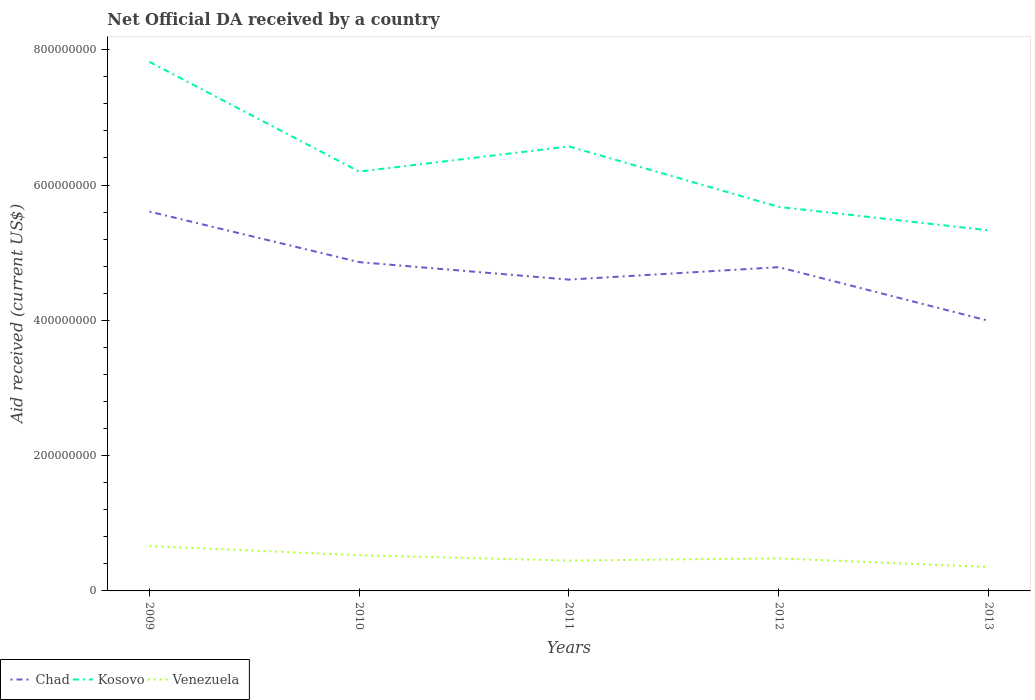Is the number of lines equal to the number of legend labels?
Your response must be concise. Yes. Across all years, what is the maximum net official development assistance aid received in Chad?
Provide a short and direct response. 3.99e+08. What is the total net official development assistance aid received in Kosovo in the graph?
Keep it short and to the point. -3.72e+07. What is the difference between the highest and the second highest net official development assistance aid received in Kosovo?
Keep it short and to the point. 2.49e+08. Is the net official development assistance aid received in Venezuela strictly greater than the net official development assistance aid received in Chad over the years?
Give a very brief answer. Yes. Are the values on the major ticks of Y-axis written in scientific E-notation?
Your response must be concise. No. How many legend labels are there?
Provide a short and direct response. 3. What is the title of the graph?
Give a very brief answer. Net Official DA received by a country. What is the label or title of the X-axis?
Offer a terse response. Years. What is the label or title of the Y-axis?
Offer a very short reply. Aid received (current US$). What is the Aid received (current US$) of Chad in 2009?
Ensure brevity in your answer.  5.61e+08. What is the Aid received (current US$) of Kosovo in 2009?
Offer a terse response. 7.82e+08. What is the Aid received (current US$) in Venezuela in 2009?
Offer a very short reply. 6.63e+07. What is the Aid received (current US$) in Chad in 2010?
Keep it short and to the point. 4.86e+08. What is the Aid received (current US$) of Kosovo in 2010?
Your response must be concise. 6.20e+08. What is the Aid received (current US$) of Venezuela in 2010?
Offer a very short reply. 5.27e+07. What is the Aid received (current US$) in Chad in 2011?
Your answer should be compact. 4.60e+08. What is the Aid received (current US$) of Kosovo in 2011?
Provide a short and direct response. 6.57e+08. What is the Aid received (current US$) in Venezuela in 2011?
Your answer should be very brief. 4.49e+07. What is the Aid received (current US$) of Chad in 2012?
Give a very brief answer. 4.79e+08. What is the Aid received (current US$) of Kosovo in 2012?
Ensure brevity in your answer.  5.68e+08. What is the Aid received (current US$) in Venezuela in 2012?
Ensure brevity in your answer.  4.81e+07. What is the Aid received (current US$) in Chad in 2013?
Provide a short and direct response. 3.99e+08. What is the Aid received (current US$) in Kosovo in 2013?
Your answer should be compact. 5.33e+08. What is the Aid received (current US$) of Venezuela in 2013?
Give a very brief answer. 3.54e+07. Across all years, what is the maximum Aid received (current US$) in Chad?
Your answer should be very brief. 5.61e+08. Across all years, what is the maximum Aid received (current US$) in Kosovo?
Your answer should be very brief. 7.82e+08. Across all years, what is the maximum Aid received (current US$) of Venezuela?
Provide a short and direct response. 6.63e+07. Across all years, what is the minimum Aid received (current US$) in Chad?
Ensure brevity in your answer.  3.99e+08. Across all years, what is the minimum Aid received (current US$) in Kosovo?
Your answer should be compact. 5.33e+08. Across all years, what is the minimum Aid received (current US$) of Venezuela?
Your answer should be very brief. 3.54e+07. What is the total Aid received (current US$) in Chad in the graph?
Offer a terse response. 2.38e+09. What is the total Aid received (current US$) in Kosovo in the graph?
Your response must be concise. 3.16e+09. What is the total Aid received (current US$) of Venezuela in the graph?
Provide a succinct answer. 2.47e+08. What is the difference between the Aid received (current US$) of Chad in 2009 and that in 2010?
Give a very brief answer. 7.47e+07. What is the difference between the Aid received (current US$) in Kosovo in 2009 and that in 2010?
Give a very brief answer. 1.62e+08. What is the difference between the Aid received (current US$) in Venezuela in 2009 and that in 2010?
Give a very brief answer. 1.36e+07. What is the difference between the Aid received (current US$) of Chad in 2009 and that in 2011?
Give a very brief answer. 1.01e+08. What is the difference between the Aid received (current US$) of Kosovo in 2009 and that in 2011?
Provide a succinct answer. 1.25e+08. What is the difference between the Aid received (current US$) in Venezuela in 2009 and that in 2011?
Your response must be concise. 2.15e+07. What is the difference between the Aid received (current US$) of Chad in 2009 and that in 2012?
Your response must be concise. 8.21e+07. What is the difference between the Aid received (current US$) in Kosovo in 2009 and that in 2012?
Keep it short and to the point. 2.14e+08. What is the difference between the Aid received (current US$) of Venezuela in 2009 and that in 2012?
Your response must be concise. 1.82e+07. What is the difference between the Aid received (current US$) in Chad in 2009 and that in 2013?
Ensure brevity in your answer.  1.61e+08. What is the difference between the Aid received (current US$) of Kosovo in 2009 and that in 2013?
Make the answer very short. 2.49e+08. What is the difference between the Aid received (current US$) in Venezuela in 2009 and that in 2013?
Your answer should be compact. 3.09e+07. What is the difference between the Aid received (current US$) of Chad in 2010 and that in 2011?
Provide a short and direct response. 2.58e+07. What is the difference between the Aid received (current US$) in Kosovo in 2010 and that in 2011?
Your answer should be very brief. -3.72e+07. What is the difference between the Aid received (current US$) in Venezuela in 2010 and that in 2011?
Your answer should be compact. 7.87e+06. What is the difference between the Aid received (current US$) of Chad in 2010 and that in 2012?
Offer a terse response. 7.45e+06. What is the difference between the Aid received (current US$) of Kosovo in 2010 and that in 2012?
Your answer should be compact. 5.22e+07. What is the difference between the Aid received (current US$) of Venezuela in 2010 and that in 2012?
Offer a very short reply. 4.61e+06. What is the difference between the Aid received (current US$) in Chad in 2010 and that in 2013?
Provide a succinct answer. 8.67e+07. What is the difference between the Aid received (current US$) in Kosovo in 2010 and that in 2013?
Keep it short and to the point. 8.68e+07. What is the difference between the Aid received (current US$) in Venezuela in 2010 and that in 2013?
Offer a terse response. 1.73e+07. What is the difference between the Aid received (current US$) in Chad in 2011 and that in 2012?
Ensure brevity in your answer.  -1.84e+07. What is the difference between the Aid received (current US$) in Kosovo in 2011 and that in 2012?
Your answer should be very brief. 8.94e+07. What is the difference between the Aid received (current US$) in Venezuela in 2011 and that in 2012?
Ensure brevity in your answer.  -3.26e+06. What is the difference between the Aid received (current US$) of Chad in 2011 and that in 2013?
Your answer should be very brief. 6.09e+07. What is the difference between the Aid received (current US$) in Kosovo in 2011 and that in 2013?
Offer a very short reply. 1.24e+08. What is the difference between the Aid received (current US$) of Venezuela in 2011 and that in 2013?
Your answer should be compact. 9.47e+06. What is the difference between the Aid received (current US$) of Chad in 2012 and that in 2013?
Provide a succinct answer. 7.93e+07. What is the difference between the Aid received (current US$) of Kosovo in 2012 and that in 2013?
Give a very brief answer. 3.46e+07. What is the difference between the Aid received (current US$) in Venezuela in 2012 and that in 2013?
Offer a very short reply. 1.27e+07. What is the difference between the Aid received (current US$) of Chad in 2009 and the Aid received (current US$) of Kosovo in 2010?
Your answer should be very brief. -5.91e+07. What is the difference between the Aid received (current US$) in Chad in 2009 and the Aid received (current US$) in Venezuela in 2010?
Keep it short and to the point. 5.08e+08. What is the difference between the Aid received (current US$) in Kosovo in 2009 and the Aid received (current US$) in Venezuela in 2010?
Give a very brief answer. 7.29e+08. What is the difference between the Aid received (current US$) of Chad in 2009 and the Aid received (current US$) of Kosovo in 2011?
Ensure brevity in your answer.  -9.64e+07. What is the difference between the Aid received (current US$) of Chad in 2009 and the Aid received (current US$) of Venezuela in 2011?
Offer a terse response. 5.16e+08. What is the difference between the Aid received (current US$) of Kosovo in 2009 and the Aid received (current US$) of Venezuela in 2011?
Keep it short and to the point. 7.37e+08. What is the difference between the Aid received (current US$) in Chad in 2009 and the Aid received (current US$) in Kosovo in 2012?
Provide a succinct answer. -6.95e+06. What is the difference between the Aid received (current US$) in Chad in 2009 and the Aid received (current US$) in Venezuela in 2012?
Offer a terse response. 5.13e+08. What is the difference between the Aid received (current US$) in Kosovo in 2009 and the Aid received (current US$) in Venezuela in 2012?
Offer a very short reply. 7.34e+08. What is the difference between the Aid received (current US$) in Chad in 2009 and the Aid received (current US$) in Kosovo in 2013?
Provide a short and direct response. 2.77e+07. What is the difference between the Aid received (current US$) of Chad in 2009 and the Aid received (current US$) of Venezuela in 2013?
Your response must be concise. 5.25e+08. What is the difference between the Aid received (current US$) in Kosovo in 2009 and the Aid received (current US$) in Venezuela in 2013?
Provide a short and direct response. 7.47e+08. What is the difference between the Aid received (current US$) of Chad in 2010 and the Aid received (current US$) of Kosovo in 2011?
Keep it short and to the point. -1.71e+08. What is the difference between the Aid received (current US$) of Chad in 2010 and the Aid received (current US$) of Venezuela in 2011?
Give a very brief answer. 4.41e+08. What is the difference between the Aid received (current US$) of Kosovo in 2010 and the Aid received (current US$) of Venezuela in 2011?
Your response must be concise. 5.75e+08. What is the difference between the Aid received (current US$) in Chad in 2010 and the Aid received (current US$) in Kosovo in 2012?
Your answer should be very brief. -8.16e+07. What is the difference between the Aid received (current US$) in Chad in 2010 and the Aid received (current US$) in Venezuela in 2012?
Your answer should be very brief. 4.38e+08. What is the difference between the Aid received (current US$) of Kosovo in 2010 and the Aid received (current US$) of Venezuela in 2012?
Provide a succinct answer. 5.72e+08. What is the difference between the Aid received (current US$) of Chad in 2010 and the Aid received (current US$) of Kosovo in 2013?
Offer a terse response. -4.70e+07. What is the difference between the Aid received (current US$) in Chad in 2010 and the Aid received (current US$) in Venezuela in 2013?
Provide a succinct answer. 4.51e+08. What is the difference between the Aid received (current US$) in Kosovo in 2010 and the Aid received (current US$) in Venezuela in 2013?
Your answer should be very brief. 5.84e+08. What is the difference between the Aid received (current US$) in Chad in 2011 and the Aid received (current US$) in Kosovo in 2012?
Give a very brief answer. -1.07e+08. What is the difference between the Aid received (current US$) in Chad in 2011 and the Aid received (current US$) in Venezuela in 2012?
Offer a terse response. 4.12e+08. What is the difference between the Aid received (current US$) of Kosovo in 2011 and the Aid received (current US$) of Venezuela in 2012?
Give a very brief answer. 6.09e+08. What is the difference between the Aid received (current US$) in Chad in 2011 and the Aid received (current US$) in Kosovo in 2013?
Provide a succinct answer. -7.28e+07. What is the difference between the Aid received (current US$) in Chad in 2011 and the Aid received (current US$) in Venezuela in 2013?
Your answer should be very brief. 4.25e+08. What is the difference between the Aid received (current US$) in Kosovo in 2011 and the Aid received (current US$) in Venezuela in 2013?
Your answer should be very brief. 6.22e+08. What is the difference between the Aid received (current US$) of Chad in 2012 and the Aid received (current US$) of Kosovo in 2013?
Provide a succinct answer. -5.44e+07. What is the difference between the Aid received (current US$) of Chad in 2012 and the Aid received (current US$) of Venezuela in 2013?
Give a very brief answer. 4.43e+08. What is the difference between the Aid received (current US$) of Kosovo in 2012 and the Aid received (current US$) of Venezuela in 2013?
Make the answer very short. 5.32e+08. What is the average Aid received (current US$) of Chad per year?
Give a very brief answer. 4.77e+08. What is the average Aid received (current US$) in Kosovo per year?
Your answer should be compact. 6.32e+08. What is the average Aid received (current US$) of Venezuela per year?
Offer a terse response. 4.95e+07. In the year 2009, what is the difference between the Aid received (current US$) in Chad and Aid received (current US$) in Kosovo?
Your response must be concise. -2.21e+08. In the year 2009, what is the difference between the Aid received (current US$) of Chad and Aid received (current US$) of Venezuela?
Make the answer very short. 4.94e+08. In the year 2009, what is the difference between the Aid received (current US$) in Kosovo and Aid received (current US$) in Venezuela?
Provide a succinct answer. 7.16e+08. In the year 2010, what is the difference between the Aid received (current US$) in Chad and Aid received (current US$) in Kosovo?
Provide a succinct answer. -1.34e+08. In the year 2010, what is the difference between the Aid received (current US$) in Chad and Aid received (current US$) in Venezuela?
Give a very brief answer. 4.33e+08. In the year 2010, what is the difference between the Aid received (current US$) of Kosovo and Aid received (current US$) of Venezuela?
Give a very brief answer. 5.67e+08. In the year 2011, what is the difference between the Aid received (current US$) in Chad and Aid received (current US$) in Kosovo?
Your answer should be very brief. -1.97e+08. In the year 2011, what is the difference between the Aid received (current US$) in Chad and Aid received (current US$) in Venezuela?
Offer a very short reply. 4.15e+08. In the year 2011, what is the difference between the Aid received (current US$) in Kosovo and Aid received (current US$) in Venezuela?
Offer a very short reply. 6.12e+08. In the year 2012, what is the difference between the Aid received (current US$) in Chad and Aid received (current US$) in Kosovo?
Keep it short and to the point. -8.91e+07. In the year 2012, what is the difference between the Aid received (current US$) in Chad and Aid received (current US$) in Venezuela?
Ensure brevity in your answer.  4.30e+08. In the year 2012, what is the difference between the Aid received (current US$) in Kosovo and Aid received (current US$) in Venezuela?
Your response must be concise. 5.20e+08. In the year 2013, what is the difference between the Aid received (current US$) of Chad and Aid received (current US$) of Kosovo?
Make the answer very short. -1.34e+08. In the year 2013, what is the difference between the Aid received (current US$) in Chad and Aid received (current US$) in Venezuela?
Ensure brevity in your answer.  3.64e+08. In the year 2013, what is the difference between the Aid received (current US$) of Kosovo and Aid received (current US$) of Venezuela?
Provide a short and direct response. 4.98e+08. What is the ratio of the Aid received (current US$) in Chad in 2009 to that in 2010?
Your answer should be very brief. 1.15. What is the ratio of the Aid received (current US$) in Kosovo in 2009 to that in 2010?
Provide a succinct answer. 1.26. What is the ratio of the Aid received (current US$) in Venezuela in 2009 to that in 2010?
Your answer should be compact. 1.26. What is the ratio of the Aid received (current US$) of Chad in 2009 to that in 2011?
Provide a short and direct response. 1.22. What is the ratio of the Aid received (current US$) in Kosovo in 2009 to that in 2011?
Keep it short and to the point. 1.19. What is the ratio of the Aid received (current US$) of Venezuela in 2009 to that in 2011?
Your response must be concise. 1.48. What is the ratio of the Aid received (current US$) in Chad in 2009 to that in 2012?
Offer a terse response. 1.17. What is the ratio of the Aid received (current US$) in Kosovo in 2009 to that in 2012?
Your response must be concise. 1.38. What is the ratio of the Aid received (current US$) in Venezuela in 2009 to that in 2012?
Offer a very short reply. 1.38. What is the ratio of the Aid received (current US$) in Chad in 2009 to that in 2013?
Provide a short and direct response. 1.4. What is the ratio of the Aid received (current US$) in Kosovo in 2009 to that in 2013?
Your response must be concise. 1.47. What is the ratio of the Aid received (current US$) in Venezuela in 2009 to that in 2013?
Provide a short and direct response. 1.87. What is the ratio of the Aid received (current US$) in Chad in 2010 to that in 2011?
Provide a succinct answer. 1.06. What is the ratio of the Aid received (current US$) of Kosovo in 2010 to that in 2011?
Provide a short and direct response. 0.94. What is the ratio of the Aid received (current US$) in Venezuela in 2010 to that in 2011?
Provide a short and direct response. 1.18. What is the ratio of the Aid received (current US$) in Chad in 2010 to that in 2012?
Your response must be concise. 1.02. What is the ratio of the Aid received (current US$) of Kosovo in 2010 to that in 2012?
Offer a very short reply. 1.09. What is the ratio of the Aid received (current US$) of Venezuela in 2010 to that in 2012?
Offer a terse response. 1.1. What is the ratio of the Aid received (current US$) of Chad in 2010 to that in 2013?
Provide a short and direct response. 1.22. What is the ratio of the Aid received (current US$) in Kosovo in 2010 to that in 2013?
Keep it short and to the point. 1.16. What is the ratio of the Aid received (current US$) of Venezuela in 2010 to that in 2013?
Keep it short and to the point. 1.49. What is the ratio of the Aid received (current US$) of Chad in 2011 to that in 2012?
Offer a very short reply. 0.96. What is the ratio of the Aid received (current US$) in Kosovo in 2011 to that in 2012?
Keep it short and to the point. 1.16. What is the ratio of the Aid received (current US$) in Venezuela in 2011 to that in 2012?
Ensure brevity in your answer.  0.93. What is the ratio of the Aid received (current US$) in Chad in 2011 to that in 2013?
Make the answer very short. 1.15. What is the ratio of the Aid received (current US$) of Kosovo in 2011 to that in 2013?
Your answer should be compact. 1.23. What is the ratio of the Aid received (current US$) of Venezuela in 2011 to that in 2013?
Make the answer very short. 1.27. What is the ratio of the Aid received (current US$) in Chad in 2012 to that in 2013?
Give a very brief answer. 1.2. What is the ratio of the Aid received (current US$) in Kosovo in 2012 to that in 2013?
Give a very brief answer. 1.06. What is the ratio of the Aid received (current US$) of Venezuela in 2012 to that in 2013?
Give a very brief answer. 1.36. What is the difference between the highest and the second highest Aid received (current US$) in Chad?
Give a very brief answer. 7.47e+07. What is the difference between the highest and the second highest Aid received (current US$) of Kosovo?
Give a very brief answer. 1.25e+08. What is the difference between the highest and the second highest Aid received (current US$) in Venezuela?
Your answer should be compact. 1.36e+07. What is the difference between the highest and the lowest Aid received (current US$) of Chad?
Give a very brief answer. 1.61e+08. What is the difference between the highest and the lowest Aid received (current US$) in Kosovo?
Offer a very short reply. 2.49e+08. What is the difference between the highest and the lowest Aid received (current US$) in Venezuela?
Your answer should be very brief. 3.09e+07. 